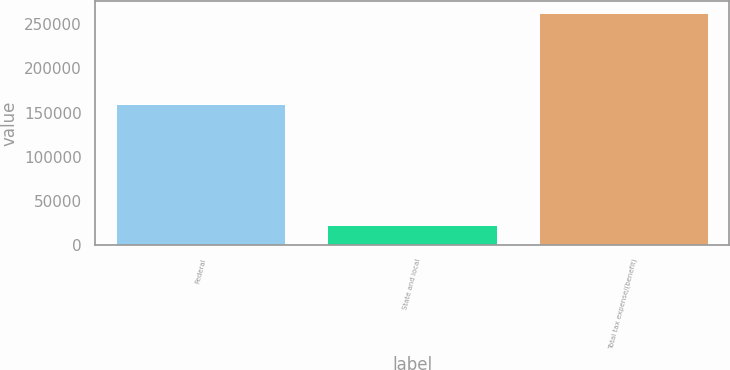<chart> <loc_0><loc_0><loc_500><loc_500><bar_chart><fcel>Federal<fcel>State and local<fcel>Total tax expense/(benefit)<nl><fcel>160235<fcel>22306<fcel>262968<nl></chart> 